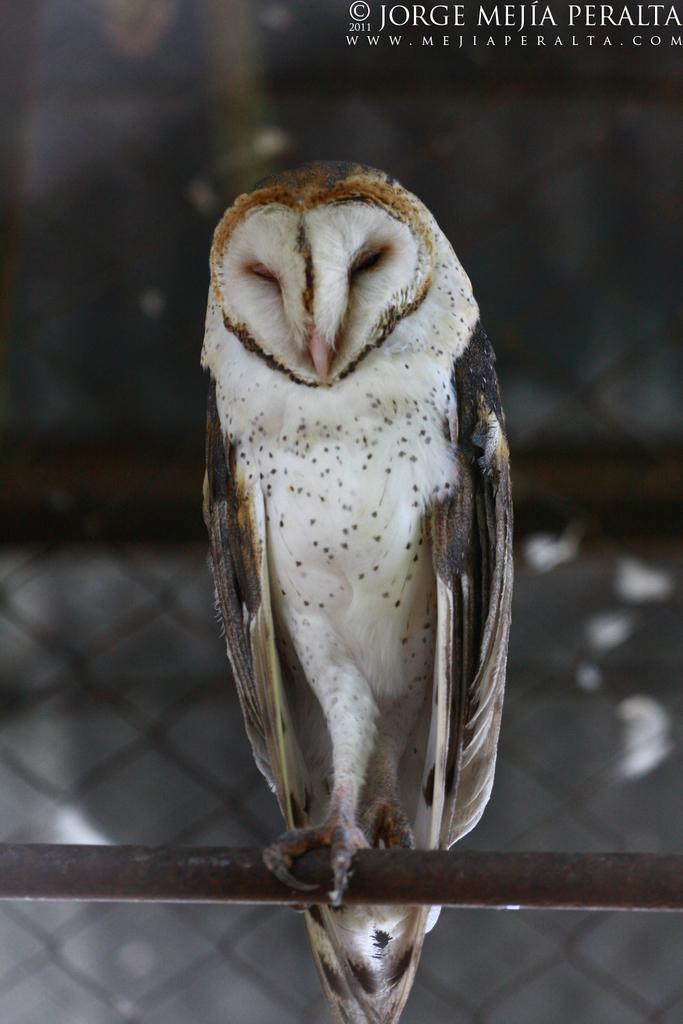What animal is present in the image? There is an owl in the image. What is the owl standing on? The owl is standing on a ride. What can be seen in the background of the image? There is fencing in the background of the image. Is there any text or logo visible in the image? Yes, there is a watermark in the top right corner of the image. What type of silk material is being rubbed on the owl's feathers in the image? There is no silk material or rubbing action present in the image; it only shows an owl standing on a ride. 